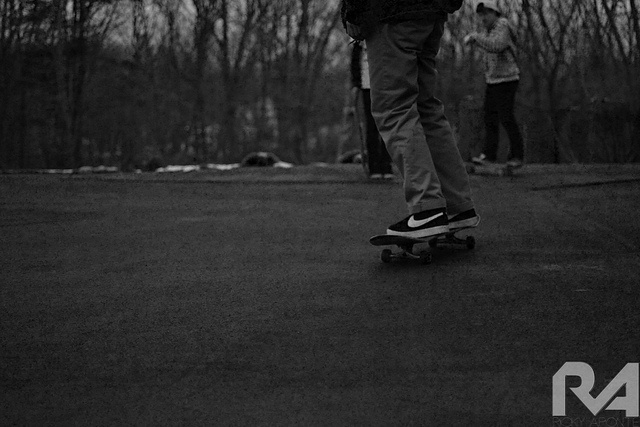Describe the objects in this image and their specific colors. I can see people in black and gray tones, people in black and gray tones, people in black and gray tones, skateboard in black and gray tones, and car in black, gray, and darkgray tones in this image. 